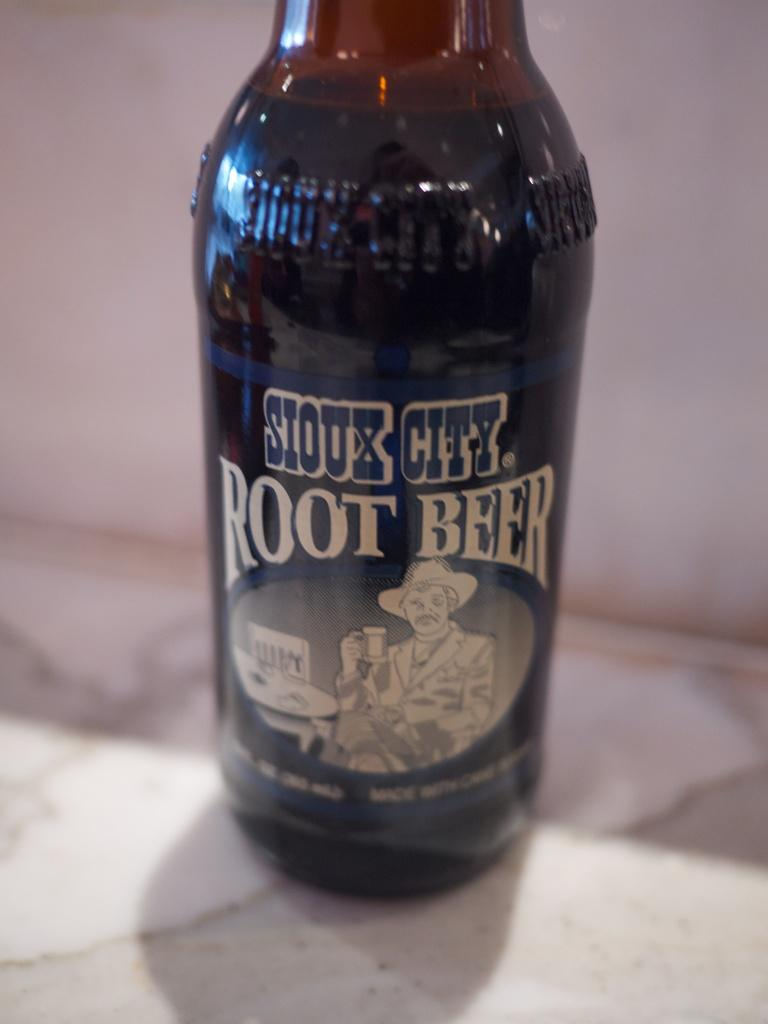<image>
Share a concise interpretation of the image provided. A bottle of Siox City Root Beer is on the counter. 